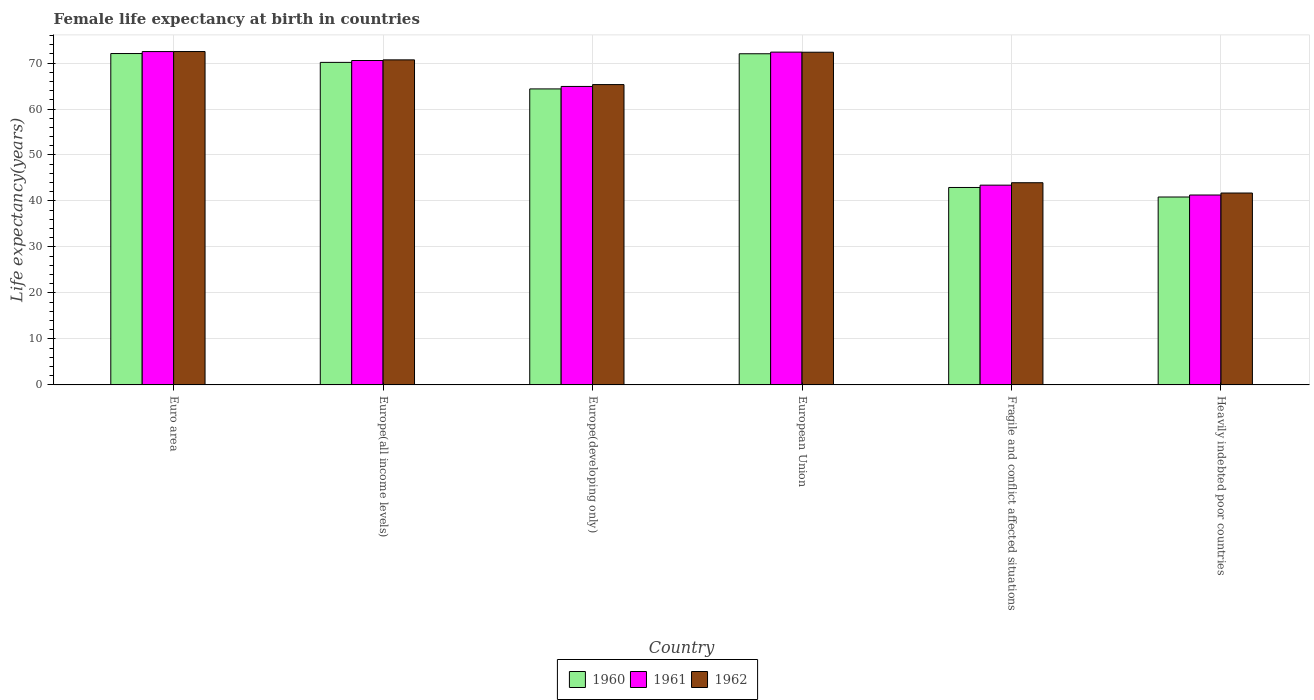Are the number of bars per tick equal to the number of legend labels?
Ensure brevity in your answer.  Yes. Are the number of bars on each tick of the X-axis equal?
Keep it short and to the point. Yes. How many bars are there on the 6th tick from the left?
Provide a short and direct response. 3. How many bars are there on the 1st tick from the right?
Your response must be concise. 3. What is the female life expectancy at birth in 1961 in Euro area?
Give a very brief answer. 72.49. Across all countries, what is the maximum female life expectancy at birth in 1961?
Your response must be concise. 72.49. Across all countries, what is the minimum female life expectancy at birth in 1962?
Ensure brevity in your answer.  41.73. In which country was the female life expectancy at birth in 1962 minimum?
Provide a short and direct response. Heavily indebted poor countries. What is the total female life expectancy at birth in 1962 in the graph?
Make the answer very short. 366.54. What is the difference between the female life expectancy at birth in 1962 in Europe(developing only) and that in European Union?
Give a very brief answer. -7.04. What is the difference between the female life expectancy at birth in 1960 in Fragile and conflict affected situations and the female life expectancy at birth in 1962 in Europe(developing only)?
Your response must be concise. -22.37. What is the average female life expectancy at birth in 1962 per country?
Keep it short and to the point. 61.09. What is the difference between the female life expectancy at birth of/in 1962 and female life expectancy at birth of/in 1960 in Europe(developing only)?
Provide a short and direct response. 0.94. What is the ratio of the female life expectancy at birth in 1961 in Euro area to that in Europe(developing only)?
Provide a short and direct response. 1.12. Is the difference between the female life expectancy at birth in 1962 in Europe(all income levels) and Fragile and conflict affected situations greater than the difference between the female life expectancy at birth in 1960 in Europe(all income levels) and Fragile and conflict affected situations?
Make the answer very short. No. What is the difference between the highest and the second highest female life expectancy at birth in 1961?
Keep it short and to the point. 0.12. What is the difference between the highest and the lowest female life expectancy at birth in 1962?
Offer a very short reply. 30.77. In how many countries, is the female life expectancy at birth in 1960 greater than the average female life expectancy at birth in 1960 taken over all countries?
Provide a succinct answer. 4. What does the 1st bar from the left in European Union represents?
Your response must be concise. 1960. Is it the case that in every country, the sum of the female life expectancy at birth in 1960 and female life expectancy at birth in 1962 is greater than the female life expectancy at birth in 1961?
Your answer should be compact. Yes. Are all the bars in the graph horizontal?
Provide a succinct answer. No. How many countries are there in the graph?
Ensure brevity in your answer.  6. What is the difference between two consecutive major ticks on the Y-axis?
Keep it short and to the point. 10. Does the graph contain grids?
Your answer should be compact. Yes. Where does the legend appear in the graph?
Keep it short and to the point. Bottom center. How many legend labels are there?
Offer a terse response. 3. What is the title of the graph?
Offer a terse response. Female life expectancy at birth in countries. Does "2014" appear as one of the legend labels in the graph?
Offer a very short reply. No. What is the label or title of the Y-axis?
Keep it short and to the point. Life expectancy(years). What is the Life expectancy(years) in 1960 in Euro area?
Provide a succinct answer. 72.06. What is the Life expectancy(years) of 1961 in Euro area?
Keep it short and to the point. 72.49. What is the Life expectancy(years) in 1962 in Euro area?
Provide a succinct answer. 72.5. What is the Life expectancy(years) in 1960 in Europe(all income levels)?
Your answer should be compact. 70.14. What is the Life expectancy(years) in 1961 in Europe(all income levels)?
Your answer should be very brief. 70.55. What is the Life expectancy(years) of 1962 in Europe(all income levels)?
Offer a very short reply. 70.69. What is the Life expectancy(years) in 1960 in Europe(developing only)?
Give a very brief answer. 64.37. What is the Life expectancy(years) in 1961 in Europe(developing only)?
Offer a very short reply. 64.91. What is the Life expectancy(years) in 1962 in Europe(developing only)?
Give a very brief answer. 65.31. What is the Life expectancy(years) in 1960 in European Union?
Keep it short and to the point. 72.02. What is the Life expectancy(years) of 1961 in European Union?
Provide a succinct answer. 72.37. What is the Life expectancy(years) of 1962 in European Union?
Offer a very short reply. 72.35. What is the Life expectancy(years) of 1960 in Fragile and conflict affected situations?
Give a very brief answer. 42.94. What is the Life expectancy(years) of 1961 in Fragile and conflict affected situations?
Make the answer very short. 43.44. What is the Life expectancy(years) in 1962 in Fragile and conflict affected situations?
Your answer should be compact. 43.97. What is the Life expectancy(years) of 1960 in Heavily indebted poor countries?
Provide a succinct answer. 40.86. What is the Life expectancy(years) in 1961 in Heavily indebted poor countries?
Ensure brevity in your answer.  41.3. What is the Life expectancy(years) of 1962 in Heavily indebted poor countries?
Keep it short and to the point. 41.73. Across all countries, what is the maximum Life expectancy(years) of 1960?
Offer a very short reply. 72.06. Across all countries, what is the maximum Life expectancy(years) in 1961?
Provide a short and direct response. 72.49. Across all countries, what is the maximum Life expectancy(years) of 1962?
Give a very brief answer. 72.5. Across all countries, what is the minimum Life expectancy(years) in 1960?
Give a very brief answer. 40.86. Across all countries, what is the minimum Life expectancy(years) of 1961?
Offer a terse response. 41.3. Across all countries, what is the minimum Life expectancy(years) in 1962?
Your response must be concise. 41.73. What is the total Life expectancy(years) in 1960 in the graph?
Keep it short and to the point. 362.39. What is the total Life expectancy(years) in 1961 in the graph?
Ensure brevity in your answer.  365.05. What is the total Life expectancy(years) in 1962 in the graph?
Ensure brevity in your answer.  366.54. What is the difference between the Life expectancy(years) of 1960 in Euro area and that in Europe(all income levels)?
Provide a succinct answer. 1.92. What is the difference between the Life expectancy(years) of 1961 in Euro area and that in Europe(all income levels)?
Provide a short and direct response. 1.94. What is the difference between the Life expectancy(years) of 1962 in Euro area and that in Europe(all income levels)?
Give a very brief answer. 1.81. What is the difference between the Life expectancy(years) of 1960 in Euro area and that in Europe(developing only)?
Your answer should be very brief. 7.69. What is the difference between the Life expectancy(years) of 1961 in Euro area and that in Europe(developing only)?
Your response must be concise. 7.59. What is the difference between the Life expectancy(years) of 1962 in Euro area and that in Europe(developing only)?
Your answer should be compact. 7.19. What is the difference between the Life expectancy(years) in 1960 in Euro area and that in European Union?
Give a very brief answer. 0.05. What is the difference between the Life expectancy(years) in 1961 in Euro area and that in European Union?
Your response must be concise. 0.12. What is the difference between the Life expectancy(years) in 1962 in Euro area and that in European Union?
Provide a short and direct response. 0.15. What is the difference between the Life expectancy(years) in 1960 in Euro area and that in Fragile and conflict affected situations?
Make the answer very short. 29.13. What is the difference between the Life expectancy(years) of 1961 in Euro area and that in Fragile and conflict affected situations?
Your answer should be very brief. 29.05. What is the difference between the Life expectancy(years) in 1962 in Euro area and that in Fragile and conflict affected situations?
Offer a very short reply. 28.53. What is the difference between the Life expectancy(years) in 1960 in Euro area and that in Heavily indebted poor countries?
Your response must be concise. 31.2. What is the difference between the Life expectancy(years) in 1961 in Euro area and that in Heavily indebted poor countries?
Offer a terse response. 31.19. What is the difference between the Life expectancy(years) in 1962 in Euro area and that in Heavily indebted poor countries?
Offer a terse response. 30.77. What is the difference between the Life expectancy(years) of 1960 in Europe(all income levels) and that in Europe(developing only)?
Offer a very short reply. 5.77. What is the difference between the Life expectancy(years) of 1961 in Europe(all income levels) and that in Europe(developing only)?
Your answer should be very brief. 5.64. What is the difference between the Life expectancy(years) of 1962 in Europe(all income levels) and that in Europe(developing only)?
Offer a very short reply. 5.38. What is the difference between the Life expectancy(years) in 1960 in Europe(all income levels) and that in European Union?
Keep it short and to the point. -1.87. What is the difference between the Life expectancy(years) of 1961 in Europe(all income levels) and that in European Union?
Provide a succinct answer. -1.83. What is the difference between the Life expectancy(years) of 1962 in Europe(all income levels) and that in European Union?
Make the answer very short. -1.66. What is the difference between the Life expectancy(years) in 1960 in Europe(all income levels) and that in Fragile and conflict affected situations?
Provide a succinct answer. 27.2. What is the difference between the Life expectancy(years) in 1961 in Europe(all income levels) and that in Fragile and conflict affected situations?
Make the answer very short. 27.11. What is the difference between the Life expectancy(years) of 1962 in Europe(all income levels) and that in Fragile and conflict affected situations?
Your answer should be very brief. 26.72. What is the difference between the Life expectancy(years) in 1960 in Europe(all income levels) and that in Heavily indebted poor countries?
Your answer should be compact. 29.28. What is the difference between the Life expectancy(years) of 1961 in Europe(all income levels) and that in Heavily indebted poor countries?
Keep it short and to the point. 29.25. What is the difference between the Life expectancy(years) of 1962 in Europe(all income levels) and that in Heavily indebted poor countries?
Keep it short and to the point. 28.96. What is the difference between the Life expectancy(years) of 1960 in Europe(developing only) and that in European Union?
Keep it short and to the point. -7.64. What is the difference between the Life expectancy(years) of 1961 in Europe(developing only) and that in European Union?
Keep it short and to the point. -7.47. What is the difference between the Life expectancy(years) in 1962 in Europe(developing only) and that in European Union?
Offer a terse response. -7.04. What is the difference between the Life expectancy(years) of 1960 in Europe(developing only) and that in Fragile and conflict affected situations?
Your answer should be very brief. 21.44. What is the difference between the Life expectancy(years) in 1961 in Europe(developing only) and that in Fragile and conflict affected situations?
Provide a short and direct response. 21.46. What is the difference between the Life expectancy(years) of 1962 in Europe(developing only) and that in Fragile and conflict affected situations?
Provide a succinct answer. 21.34. What is the difference between the Life expectancy(years) in 1960 in Europe(developing only) and that in Heavily indebted poor countries?
Your answer should be very brief. 23.51. What is the difference between the Life expectancy(years) of 1961 in Europe(developing only) and that in Heavily indebted poor countries?
Ensure brevity in your answer.  23.61. What is the difference between the Life expectancy(years) in 1962 in Europe(developing only) and that in Heavily indebted poor countries?
Give a very brief answer. 23.58. What is the difference between the Life expectancy(years) of 1960 in European Union and that in Fragile and conflict affected situations?
Your answer should be compact. 29.08. What is the difference between the Life expectancy(years) of 1961 in European Union and that in Fragile and conflict affected situations?
Offer a very short reply. 28.93. What is the difference between the Life expectancy(years) of 1962 in European Union and that in Fragile and conflict affected situations?
Make the answer very short. 28.38. What is the difference between the Life expectancy(years) in 1960 in European Union and that in Heavily indebted poor countries?
Your answer should be very brief. 31.15. What is the difference between the Life expectancy(years) in 1961 in European Union and that in Heavily indebted poor countries?
Provide a succinct answer. 31.07. What is the difference between the Life expectancy(years) in 1962 in European Union and that in Heavily indebted poor countries?
Make the answer very short. 30.62. What is the difference between the Life expectancy(years) in 1960 in Fragile and conflict affected situations and that in Heavily indebted poor countries?
Your answer should be very brief. 2.07. What is the difference between the Life expectancy(years) of 1961 in Fragile and conflict affected situations and that in Heavily indebted poor countries?
Make the answer very short. 2.14. What is the difference between the Life expectancy(years) in 1962 in Fragile and conflict affected situations and that in Heavily indebted poor countries?
Make the answer very short. 2.24. What is the difference between the Life expectancy(years) in 1960 in Euro area and the Life expectancy(years) in 1961 in Europe(all income levels)?
Your response must be concise. 1.52. What is the difference between the Life expectancy(years) in 1960 in Euro area and the Life expectancy(years) in 1962 in Europe(all income levels)?
Your answer should be very brief. 1.38. What is the difference between the Life expectancy(years) of 1961 in Euro area and the Life expectancy(years) of 1962 in Europe(all income levels)?
Offer a very short reply. 1.8. What is the difference between the Life expectancy(years) in 1960 in Euro area and the Life expectancy(years) in 1961 in Europe(developing only)?
Keep it short and to the point. 7.16. What is the difference between the Life expectancy(years) of 1960 in Euro area and the Life expectancy(years) of 1962 in Europe(developing only)?
Provide a short and direct response. 6.75. What is the difference between the Life expectancy(years) in 1961 in Euro area and the Life expectancy(years) in 1962 in Europe(developing only)?
Provide a short and direct response. 7.18. What is the difference between the Life expectancy(years) of 1960 in Euro area and the Life expectancy(years) of 1961 in European Union?
Give a very brief answer. -0.31. What is the difference between the Life expectancy(years) in 1960 in Euro area and the Life expectancy(years) in 1962 in European Union?
Make the answer very short. -0.28. What is the difference between the Life expectancy(years) in 1961 in Euro area and the Life expectancy(years) in 1962 in European Union?
Offer a terse response. 0.14. What is the difference between the Life expectancy(years) of 1960 in Euro area and the Life expectancy(years) of 1961 in Fragile and conflict affected situations?
Offer a terse response. 28.62. What is the difference between the Life expectancy(years) in 1960 in Euro area and the Life expectancy(years) in 1962 in Fragile and conflict affected situations?
Make the answer very short. 28.1. What is the difference between the Life expectancy(years) of 1961 in Euro area and the Life expectancy(years) of 1962 in Fragile and conflict affected situations?
Offer a terse response. 28.52. What is the difference between the Life expectancy(years) in 1960 in Euro area and the Life expectancy(years) in 1961 in Heavily indebted poor countries?
Provide a short and direct response. 30.76. What is the difference between the Life expectancy(years) of 1960 in Euro area and the Life expectancy(years) of 1962 in Heavily indebted poor countries?
Your response must be concise. 30.34. What is the difference between the Life expectancy(years) of 1961 in Euro area and the Life expectancy(years) of 1962 in Heavily indebted poor countries?
Make the answer very short. 30.76. What is the difference between the Life expectancy(years) in 1960 in Europe(all income levels) and the Life expectancy(years) in 1961 in Europe(developing only)?
Keep it short and to the point. 5.24. What is the difference between the Life expectancy(years) of 1960 in Europe(all income levels) and the Life expectancy(years) of 1962 in Europe(developing only)?
Offer a terse response. 4.83. What is the difference between the Life expectancy(years) in 1961 in Europe(all income levels) and the Life expectancy(years) in 1962 in Europe(developing only)?
Provide a succinct answer. 5.24. What is the difference between the Life expectancy(years) of 1960 in Europe(all income levels) and the Life expectancy(years) of 1961 in European Union?
Your response must be concise. -2.23. What is the difference between the Life expectancy(years) of 1960 in Europe(all income levels) and the Life expectancy(years) of 1962 in European Union?
Provide a succinct answer. -2.21. What is the difference between the Life expectancy(years) of 1961 in Europe(all income levels) and the Life expectancy(years) of 1962 in European Union?
Make the answer very short. -1.8. What is the difference between the Life expectancy(years) in 1960 in Europe(all income levels) and the Life expectancy(years) in 1961 in Fragile and conflict affected situations?
Ensure brevity in your answer.  26.7. What is the difference between the Life expectancy(years) of 1960 in Europe(all income levels) and the Life expectancy(years) of 1962 in Fragile and conflict affected situations?
Provide a short and direct response. 26.17. What is the difference between the Life expectancy(years) in 1961 in Europe(all income levels) and the Life expectancy(years) in 1962 in Fragile and conflict affected situations?
Your answer should be very brief. 26.58. What is the difference between the Life expectancy(years) in 1960 in Europe(all income levels) and the Life expectancy(years) in 1961 in Heavily indebted poor countries?
Provide a short and direct response. 28.84. What is the difference between the Life expectancy(years) in 1960 in Europe(all income levels) and the Life expectancy(years) in 1962 in Heavily indebted poor countries?
Provide a succinct answer. 28.41. What is the difference between the Life expectancy(years) in 1961 in Europe(all income levels) and the Life expectancy(years) in 1962 in Heavily indebted poor countries?
Provide a short and direct response. 28.82. What is the difference between the Life expectancy(years) of 1960 in Europe(developing only) and the Life expectancy(years) of 1961 in European Union?
Make the answer very short. -8. What is the difference between the Life expectancy(years) of 1960 in Europe(developing only) and the Life expectancy(years) of 1962 in European Union?
Give a very brief answer. -7.98. What is the difference between the Life expectancy(years) in 1961 in Europe(developing only) and the Life expectancy(years) in 1962 in European Union?
Ensure brevity in your answer.  -7.44. What is the difference between the Life expectancy(years) in 1960 in Europe(developing only) and the Life expectancy(years) in 1961 in Fragile and conflict affected situations?
Give a very brief answer. 20.93. What is the difference between the Life expectancy(years) in 1960 in Europe(developing only) and the Life expectancy(years) in 1962 in Fragile and conflict affected situations?
Offer a terse response. 20.4. What is the difference between the Life expectancy(years) in 1961 in Europe(developing only) and the Life expectancy(years) in 1962 in Fragile and conflict affected situations?
Provide a short and direct response. 20.94. What is the difference between the Life expectancy(years) of 1960 in Europe(developing only) and the Life expectancy(years) of 1961 in Heavily indebted poor countries?
Your answer should be compact. 23.07. What is the difference between the Life expectancy(years) in 1960 in Europe(developing only) and the Life expectancy(years) in 1962 in Heavily indebted poor countries?
Your response must be concise. 22.64. What is the difference between the Life expectancy(years) in 1961 in Europe(developing only) and the Life expectancy(years) in 1962 in Heavily indebted poor countries?
Keep it short and to the point. 23.18. What is the difference between the Life expectancy(years) of 1960 in European Union and the Life expectancy(years) of 1961 in Fragile and conflict affected situations?
Provide a succinct answer. 28.57. What is the difference between the Life expectancy(years) in 1960 in European Union and the Life expectancy(years) in 1962 in Fragile and conflict affected situations?
Keep it short and to the point. 28.05. What is the difference between the Life expectancy(years) in 1961 in European Union and the Life expectancy(years) in 1962 in Fragile and conflict affected situations?
Offer a very short reply. 28.41. What is the difference between the Life expectancy(years) in 1960 in European Union and the Life expectancy(years) in 1961 in Heavily indebted poor countries?
Make the answer very short. 30.72. What is the difference between the Life expectancy(years) in 1960 in European Union and the Life expectancy(years) in 1962 in Heavily indebted poor countries?
Your answer should be compact. 30.29. What is the difference between the Life expectancy(years) in 1961 in European Union and the Life expectancy(years) in 1962 in Heavily indebted poor countries?
Keep it short and to the point. 30.64. What is the difference between the Life expectancy(years) of 1960 in Fragile and conflict affected situations and the Life expectancy(years) of 1961 in Heavily indebted poor countries?
Your response must be concise. 1.64. What is the difference between the Life expectancy(years) in 1960 in Fragile and conflict affected situations and the Life expectancy(years) in 1962 in Heavily indebted poor countries?
Keep it short and to the point. 1.21. What is the difference between the Life expectancy(years) of 1961 in Fragile and conflict affected situations and the Life expectancy(years) of 1962 in Heavily indebted poor countries?
Ensure brevity in your answer.  1.71. What is the average Life expectancy(years) in 1960 per country?
Keep it short and to the point. 60.4. What is the average Life expectancy(years) of 1961 per country?
Give a very brief answer. 60.84. What is the average Life expectancy(years) of 1962 per country?
Your answer should be compact. 61.09. What is the difference between the Life expectancy(years) of 1960 and Life expectancy(years) of 1961 in Euro area?
Your answer should be very brief. -0.43. What is the difference between the Life expectancy(years) of 1960 and Life expectancy(years) of 1962 in Euro area?
Provide a short and direct response. -0.43. What is the difference between the Life expectancy(years) in 1961 and Life expectancy(years) in 1962 in Euro area?
Your answer should be very brief. -0.01. What is the difference between the Life expectancy(years) of 1960 and Life expectancy(years) of 1961 in Europe(all income levels)?
Give a very brief answer. -0.41. What is the difference between the Life expectancy(years) in 1960 and Life expectancy(years) in 1962 in Europe(all income levels)?
Provide a succinct answer. -0.55. What is the difference between the Life expectancy(years) of 1961 and Life expectancy(years) of 1962 in Europe(all income levels)?
Offer a very short reply. -0.14. What is the difference between the Life expectancy(years) in 1960 and Life expectancy(years) in 1961 in Europe(developing only)?
Ensure brevity in your answer.  -0.53. What is the difference between the Life expectancy(years) of 1960 and Life expectancy(years) of 1962 in Europe(developing only)?
Give a very brief answer. -0.94. What is the difference between the Life expectancy(years) in 1961 and Life expectancy(years) in 1962 in Europe(developing only)?
Offer a terse response. -0.41. What is the difference between the Life expectancy(years) in 1960 and Life expectancy(years) in 1961 in European Union?
Offer a terse response. -0.36. What is the difference between the Life expectancy(years) of 1960 and Life expectancy(years) of 1962 in European Union?
Offer a terse response. -0.33. What is the difference between the Life expectancy(years) of 1961 and Life expectancy(years) of 1962 in European Union?
Your response must be concise. 0.03. What is the difference between the Life expectancy(years) in 1960 and Life expectancy(years) in 1961 in Fragile and conflict affected situations?
Make the answer very short. -0.5. What is the difference between the Life expectancy(years) of 1960 and Life expectancy(years) of 1962 in Fragile and conflict affected situations?
Your response must be concise. -1.03. What is the difference between the Life expectancy(years) in 1961 and Life expectancy(years) in 1962 in Fragile and conflict affected situations?
Offer a very short reply. -0.53. What is the difference between the Life expectancy(years) of 1960 and Life expectancy(years) of 1961 in Heavily indebted poor countries?
Offer a very short reply. -0.44. What is the difference between the Life expectancy(years) in 1960 and Life expectancy(years) in 1962 in Heavily indebted poor countries?
Make the answer very short. -0.87. What is the difference between the Life expectancy(years) in 1961 and Life expectancy(years) in 1962 in Heavily indebted poor countries?
Your answer should be very brief. -0.43. What is the ratio of the Life expectancy(years) of 1960 in Euro area to that in Europe(all income levels)?
Provide a succinct answer. 1.03. What is the ratio of the Life expectancy(years) in 1961 in Euro area to that in Europe(all income levels)?
Your answer should be compact. 1.03. What is the ratio of the Life expectancy(years) of 1962 in Euro area to that in Europe(all income levels)?
Provide a succinct answer. 1.03. What is the ratio of the Life expectancy(years) in 1960 in Euro area to that in Europe(developing only)?
Your answer should be compact. 1.12. What is the ratio of the Life expectancy(years) in 1961 in Euro area to that in Europe(developing only)?
Your answer should be very brief. 1.12. What is the ratio of the Life expectancy(years) in 1962 in Euro area to that in Europe(developing only)?
Provide a short and direct response. 1.11. What is the ratio of the Life expectancy(years) in 1960 in Euro area to that in Fragile and conflict affected situations?
Provide a succinct answer. 1.68. What is the ratio of the Life expectancy(years) of 1961 in Euro area to that in Fragile and conflict affected situations?
Provide a short and direct response. 1.67. What is the ratio of the Life expectancy(years) of 1962 in Euro area to that in Fragile and conflict affected situations?
Provide a short and direct response. 1.65. What is the ratio of the Life expectancy(years) in 1960 in Euro area to that in Heavily indebted poor countries?
Provide a succinct answer. 1.76. What is the ratio of the Life expectancy(years) in 1961 in Euro area to that in Heavily indebted poor countries?
Your response must be concise. 1.76. What is the ratio of the Life expectancy(years) of 1962 in Euro area to that in Heavily indebted poor countries?
Offer a very short reply. 1.74. What is the ratio of the Life expectancy(years) in 1960 in Europe(all income levels) to that in Europe(developing only)?
Offer a very short reply. 1.09. What is the ratio of the Life expectancy(years) in 1961 in Europe(all income levels) to that in Europe(developing only)?
Your answer should be very brief. 1.09. What is the ratio of the Life expectancy(years) of 1962 in Europe(all income levels) to that in Europe(developing only)?
Ensure brevity in your answer.  1.08. What is the ratio of the Life expectancy(years) in 1960 in Europe(all income levels) to that in European Union?
Offer a very short reply. 0.97. What is the ratio of the Life expectancy(years) of 1961 in Europe(all income levels) to that in European Union?
Offer a very short reply. 0.97. What is the ratio of the Life expectancy(years) of 1962 in Europe(all income levels) to that in European Union?
Your answer should be compact. 0.98. What is the ratio of the Life expectancy(years) in 1960 in Europe(all income levels) to that in Fragile and conflict affected situations?
Make the answer very short. 1.63. What is the ratio of the Life expectancy(years) of 1961 in Europe(all income levels) to that in Fragile and conflict affected situations?
Your response must be concise. 1.62. What is the ratio of the Life expectancy(years) of 1962 in Europe(all income levels) to that in Fragile and conflict affected situations?
Provide a short and direct response. 1.61. What is the ratio of the Life expectancy(years) in 1960 in Europe(all income levels) to that in Heavily indebted poor countries?
Your answer should be compact. 1.72. What is the ratio of the Life expectancy(years) in 1961 in Europe(all income levels) to that in Heavily indebted poor countries?
Give a very brief answer. 1.71. What is the ratio of the Life expectancy(years) in 1962 in Europe(all income levels) to that in Heavily indebted poor countries?
Give a very brief answer. 1.69. What is the ratio of the Life expectancy(years) in 1960 in Europe(developing only) to that in European Union?
Your answer should be compact. 0.89. What is the ratio of the Life expectancy(years) in 1961 in Europe(developing only) to that in European Union?
Ensure brevity in your answer.  0.9. What is the ratio of the Life expectancy(years) of 1962 in Europe(developing only) to that in European Union?
Provide a short and direct response. 0.9. What is the ratio of the Life expectancy(years) in 1960 in Europe(developing only) to that in Fragile and conflict affected situations?
Ensure brevity in your answer.  1.5. What is the ratio of the Life expectancy(years) of 1961 in Europe(developing only) to that in Fragile and conflict affected situations?
Make the answer very short. 1.49. What is the ratio of the Life expectancy(years) in 1962 in Europe(developing only) to that in Fragile and conflict affected situations?
Offer a very short reply. 1.49. What is the ratio of the Life expectancy(years) in 1960 in Europe(developing only) to that in Heavily indebted poor countries?
Keep it short and to the point. 1.58. What is the ratio of the Life expectancy(years) of 1961 in Europe(developing only) to that in Heavily indebted poor countries?
Make the answer very short. 1.57. What is the ratio of the Life expectancy(years) of 1962 in Europe(developing only) to that in Heavily indebted poor countries?
Provide a succinct answer. 1.57. What is the ratio of the Life expectancy(years) in 1960 in European Union to that in Fragile and conflict affected situations?
Offer a terse response. 1.68. What is the ratio of the Life expectancy(years) of 1961 in European Union to that in Fragile and conflict affected situations?
Ensure brevity in your answer.  1.67. What is the ratio of the Life expectancy(years) in 1962 in European Union to that in Fragile and conflict affected situations?
Offer a terse response. 1.65. What is the ratio of the Life expectancy(years) in 1960 in European Union to that in Heavily indebted poor countries?
Your answer should be very brief. 1.76. What is the ratio of the Life expectancy(years) of 1961 in European Union to that in Heavily indebted poor countries?
Your answer should be compact. 1.75. What is the ratio of the Life expectancy(years) in 1962 in European Union to that in Heavily indebted poor countries?
Offer a very short reply. 1.73. What is the ratio of the Life expectancy(years) of 1960 in Fragile and conflict affected situations to that in Heavily indebted poor countries?
Make the answer very short. 1.05. What is the ratio of the Life expectancy(years) of 1961 in Fragile and conflict affected situations to that in Heavily indebted poor countries?
Provide a short and direct response. 1.05. What is the ratio of the Life expectancy(years) in 1962 in Fragile and conflict affected situations to that in Heavily indebted poor countries?
Give a very brief answer. 1.05. What is the difference between the highest and the second highest Life expectancy(years) of 1960?
Your answer should be very brief. 0.05. What is the difference between the highest and the second highest Life expectancy(years) in 1961?
Your answer should be very brief. 0.12. What is the difference between the highest and the second highest Life expectancy(years) in 1962?
Offer a terse response. 0.15. What is the difference between the highest and the lowest Life expectancy(years) in 1960?
Make the answer very short. 31.2. What is the difference between the highest and the lowest Life expectancy(years) of 1961?
Provide a succinct answer. 31.19. What is the difference between the highest and the lowest Life expectancy(years) of 1962?
Ensure brevity in your answer.  30.77. 